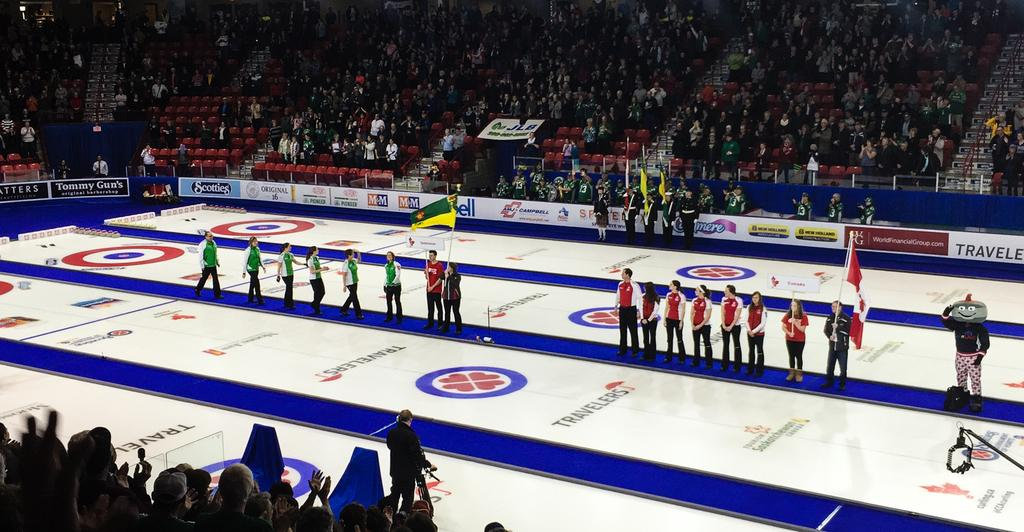<image>
Offer a succinct explanation of the picture presented. two teams standing on a blue line on court sponsored by travelers 